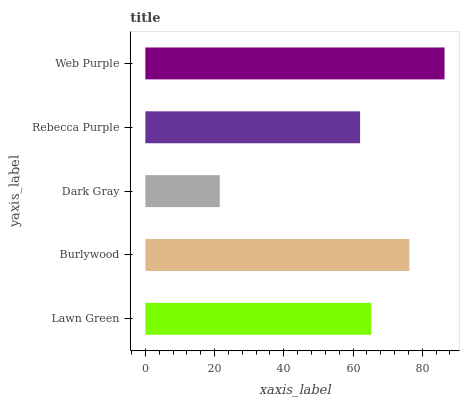Is Dark Gray the minimum?
Answer yes or no. Yes. Is Web Purple the maximum?
Answer yes or no. Yes. Is Burlywood the minimum?
Answer yes or no. No. Is Burlywood the maximum?
Answer yes or no. No. Is Burlywood greater than Lawn Green?
Answer yes or no. Yes. Is Lawn Green less than Burlywood?
Answer yes or no. Yes. Is Lawn Green greater than Burlywood?
Answer yes or no. No. Is Burlywood less than Lawn Green?
Answer yes or no. No. Is Lawn Green the high median?
Answer yes or no. Yes. Is Lawn Green the low median?
Answer yes or no. Yes. Is Burlywood the high median?
Answer yes or no. No. Is Burlywood the low median?
Answer yes or no. No. 